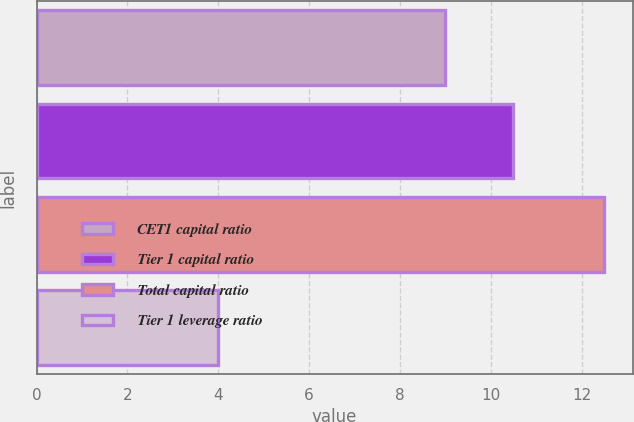Convert chart. <chart><loc_0><loc_0><loc_500><loc_500><bar_chart><fcel>CET1 capital ratio<fcel>Tier 1 capital ratio<fcel>Total capital ratio<fcel>Tier 1 leverage ratio<nl><fcel>9<fcel>10.5<fcel>12.5<fcel>4<nl></chart> 